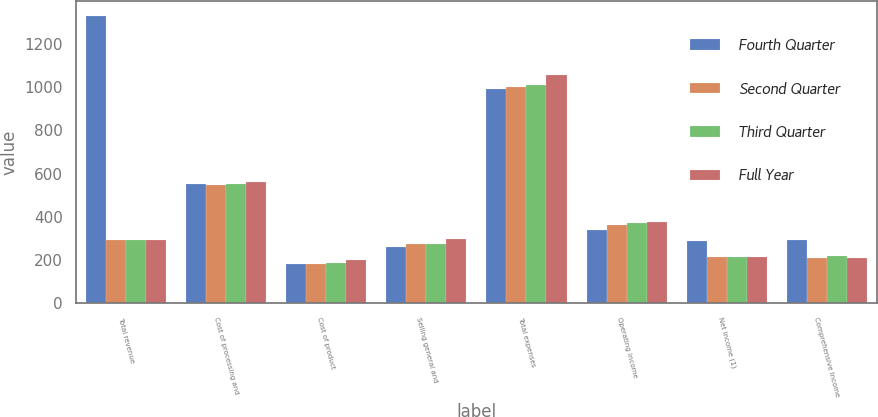Convert chart. <chart><loc_0><loc_0><loc_500><loc_500><stacked_bar_chart><ecel><fcel>Total revenue<fcel>Cost of processing and<fcel>Cost of product<fcel>Selling general and<fcel>Total expenses<fcel>Operating income<fcel>Net income (1)<fcel>Comprehensive income<nl><fcel>Fourth Quarter<fcel>1331<fcel>553<fcel>181<fcel>258<fcel>992<fcel>339<fcel>289<fcel>294<nl><fcel>Second Quarter<fcel>294<fcel>547<fcel>180<fcel>274<fcel>1001<fcel>362<fcel>212<fcel>207<nl><fcel>Third Quarter<fcel>294<fcel>551<fcel>186<fcel>274<fcel>1011<fcel>369<fcel>214<fcel>219<nl><fcel>Full Year<fcel>294<fcel>561<fcel>200<fcel>295<fcel>1056<fcel>375<fcel>215<fcel>208<nl></chart> 